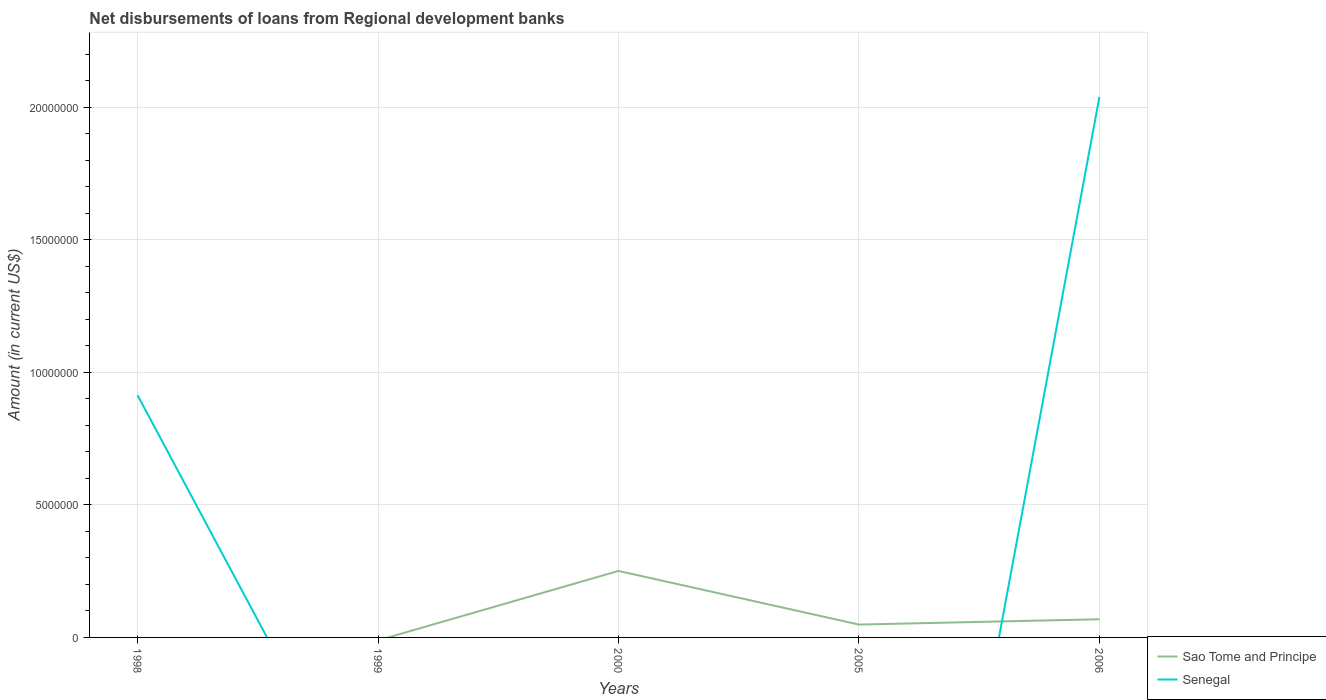Is the number of lines equal to the number of legend labels?
Make the answer very short. No. What is the total amount of disbursements of loans from regional development banks in Senegal in the graph?
Offer a very short reply. -1.13e+07. What is the difference between the highest and the second highest amount of disbursements of loans from regional development banks in Senegal?
Keep it short and to the point. 2.04e+07. How many lines are there?
Keep it short and to the point. 2. How many years are there in the graph?
Provide a succinct answer. 5. What is the difference between two consecutive major ticks on the Y-axis?
Provide a short and direct response. 5.00e+06. Does the graph contain grids?
Provide a short and direct response. Yes. How are the legend labels stacked?
Offer a very short reply. Vertical. What is the title of the graph?
Provide a short and direct response. Net disbursements of loans from Regional development banks. Does "Rwanda" appear as one of the legend labels in the graph?
Your answer should be compact. No. What is the label or title of the X-axis?
Keep it short and to the point. Years. What is the label or title of the Y-axis?
Your answer should be compact. Amount (in current US$). What is the Amount (in current US$) in Senegal in 1998?
Offer a very short reply. 9.14e+06. What is the Amount (in current US$) in Sao Tome and Principe in 1999?
Keep it short and to the point. 0. What is the Amount (in current US$) in Senegal in 1999?
Keep it short and to the point. 0. What is the Amount (in current US$) of Sao Tome and Principe in 2000?
Provide a short and direct response. 2.51e+06. What is the Amount (in current US$) in Senegal in 2000?
Make the answer very short. 0. What is the Amount (in current US$) of Sao Tome and Principe in 2005?
Offer a very short reply. 4.85e+05. What is the Amount (in current US$) of Sao Tome and Principe in 2006?
Provide a short and direct response. 6.86e+05. What is the Amount (in current US$) in Senegal in 2006?
Give a very brief answer. 2.04e+07. Across all years, what is the maximum Amount (in current US$) of Sao Tome and Principe?
Give a very brief answer. 2.51e+06. Across all years, what is the maximum Amount (in current US$) of Senegal?
Offer a terse response. 2.04e+07. What is the total Amount (in current US$) in Sao Tome and Principe in the graph?
Your answer should be very brief. 3.68e+06. What is the total Amount (in current US$) of Senegal in the graph?
Your response must be concise. 2.95e+07. What is the difference between the Amount (in current US$) of Senegal in 1998 and that in 2006?
Your response must be concise. -1.13e+07. What is the difference between the Amount (in current US$) of Sao Tome and Principe in 2000 and that in 2005?
Ensure brevity in your answer.  2.02e+06. What is the difference between the Amount (in current US$) in Sao Tome and Principe in 2000 and that in 2006?
Your answer should be compact. 1.82e+06. What is the difference between the Amount (in current US$) in Sao Tome and Principe in 2005 and that in 2006?
Provide a succinct answer. -2.01e+05. What is the difference between the Amount (in current US$) of Sao Tome and Principe in 2000 and the Amount (in current US$) of Senegal in 2006?
Provide a short and direct response. -1.79e+07. What is the difference between the Amount (in current US$) in Sao Tome and Principe in 2005 and the Amount (in current US$) in Senegal in 2006?
Provide a succinct answer. -1.99e+07. What is the average Amount (in current US$) of Sao Tome and Principe per year?
Ensure brevity in your answer.  7.36e+05. What is the average Amount (in current US$) in Senegal per year?
Your answer should be compact. 5.91e+06. In the year 2006, what is the difference between the Amount (in current US$) in Sao Tome and Principe and Amount (in current US$) in Senegal?
Offer a terse response. -1.97e+07. What is the ratio of the Amount (in current US$) in Senegal in 1998 to that in 2006?
Provide a succinct answer. 0.45. What is the ratio of the Amount (in current US$) of Sao Tome and Principe in 2000 to that in 2005?
Offer a very short reply. 5.17. What is the ratio of the Amount (in current US$) of Sao Tome and Principe in 2000 to that in 2006?
Give a very brief answer. 3.66. What is the ratio of the Amount (in current US$) in Sao Tome and Principe in 2005 to that in 2006?
Your response must be concise. 0.71. What is the difference between the highest and the second highest Amount (in current US$) in Sao Tome and Principe?
Provide a short and direct response. 1.82e+06. What is the difference between the highest and the lowest Amount (in current US$) in Sao Tome and Principe?
Keep it short and to the point. 2.51e+06. What is the difference between the highest and the lowest Amount (in current US$) in Senegal?
Keep it short and to the point. 2.04e+07. 